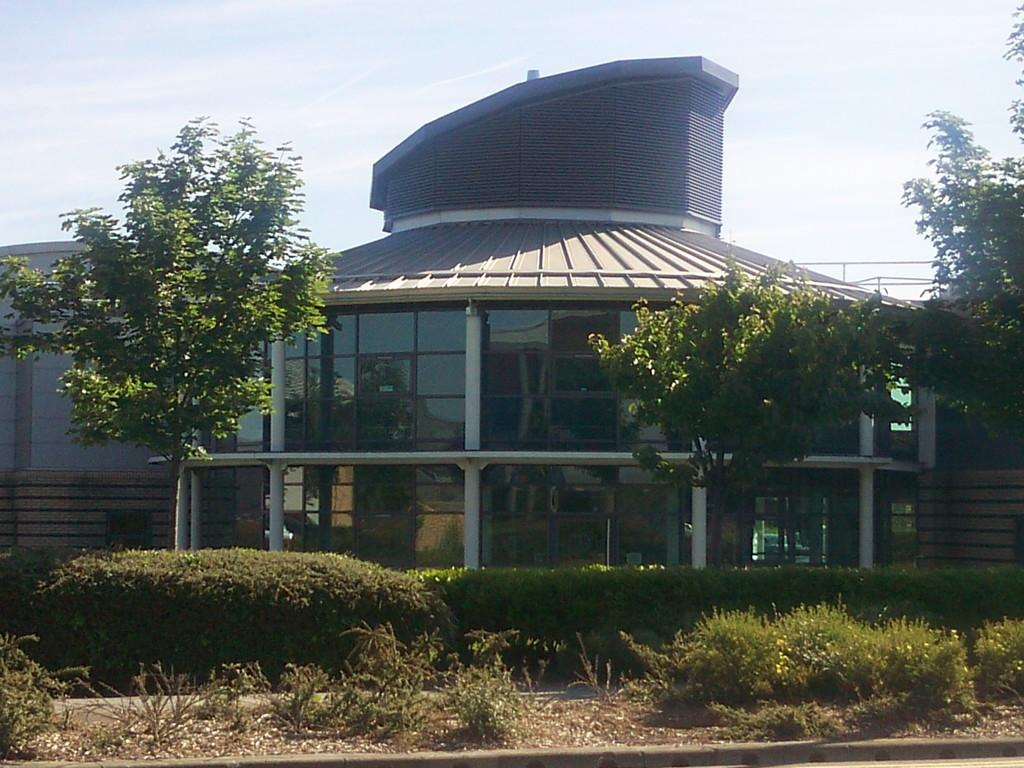What type of structure is visible in the image? There is a building in the image. What other natural elements can be seen in the image? There are trees and clouds visible in the image. What type of vegetation is present on the ground in the image? There are plants on the ground in the image. What type of brake system is installed on the trees in the image? There is no brake system present on the trees in the image; they are natural elements. 